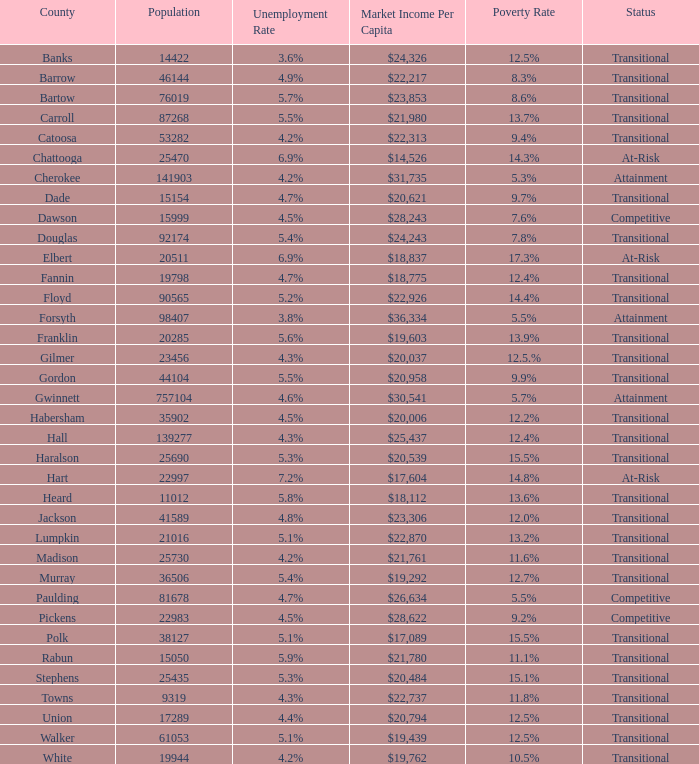What is the status of the county that has a 17.3% poverty rate? At-Risk. 